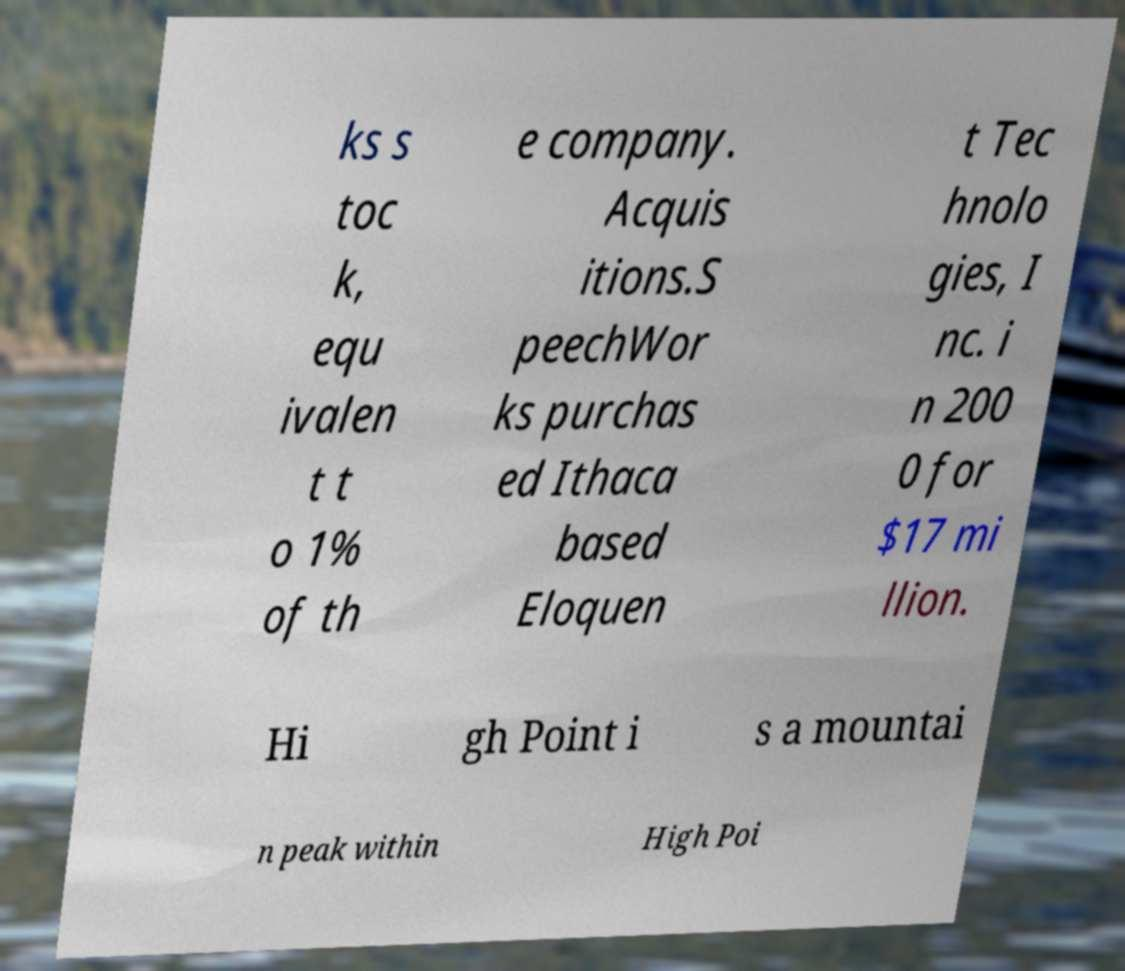Please read and relay the text visible in this image. What does it say? ks s toc k, equ ivalen t t o 1% of th e company. Acquis itions.S peechWor ks purchas ed Ithaca based Eloquen t Tec hnolo gies, I nc. i n 200 0 for $17 mi llion. Hi gh Point i s a mountai n peak within High Poi 